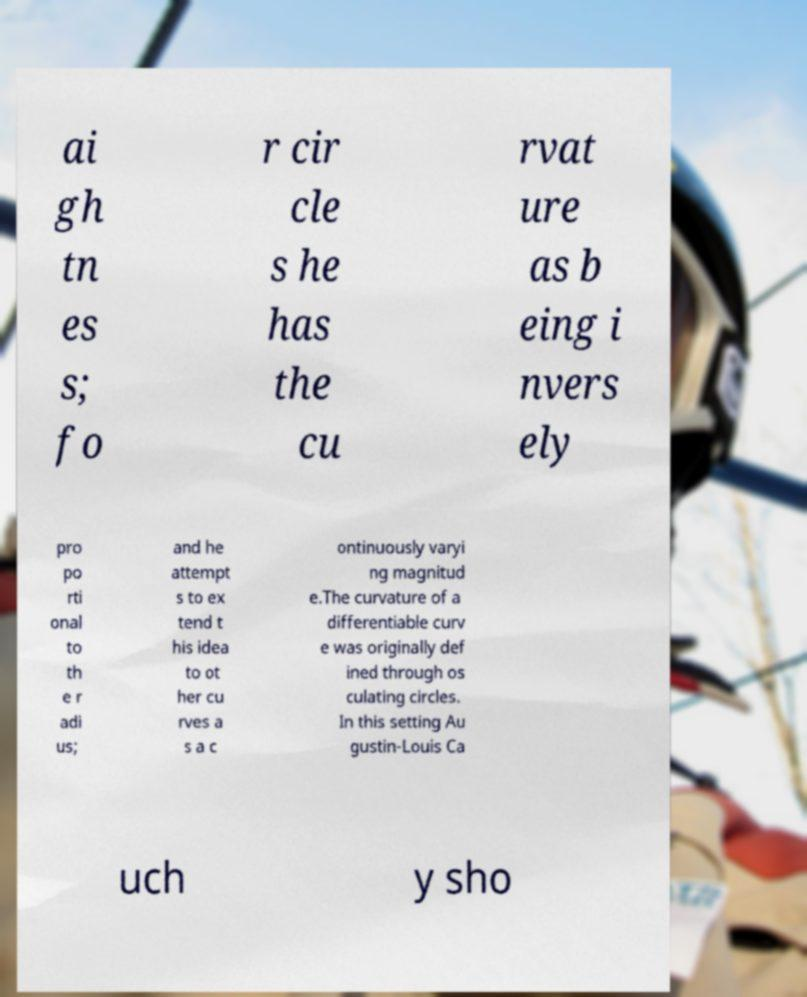I need the written content from this picture converted into text. Can you do that? ai gh tn es s; fo r cir cle s he has the cu rvat ure as b eing i nvers ely pro po rti onal to th e r adi us; and he attempt s to ex tend t his idea to ot her cu rves a s a c ontinuously varyi ng magnitud e.The curvature of a differentiable curv e was originally def ined through os culating circles. In this setting Au gustin-Louis Ca uch y sho 